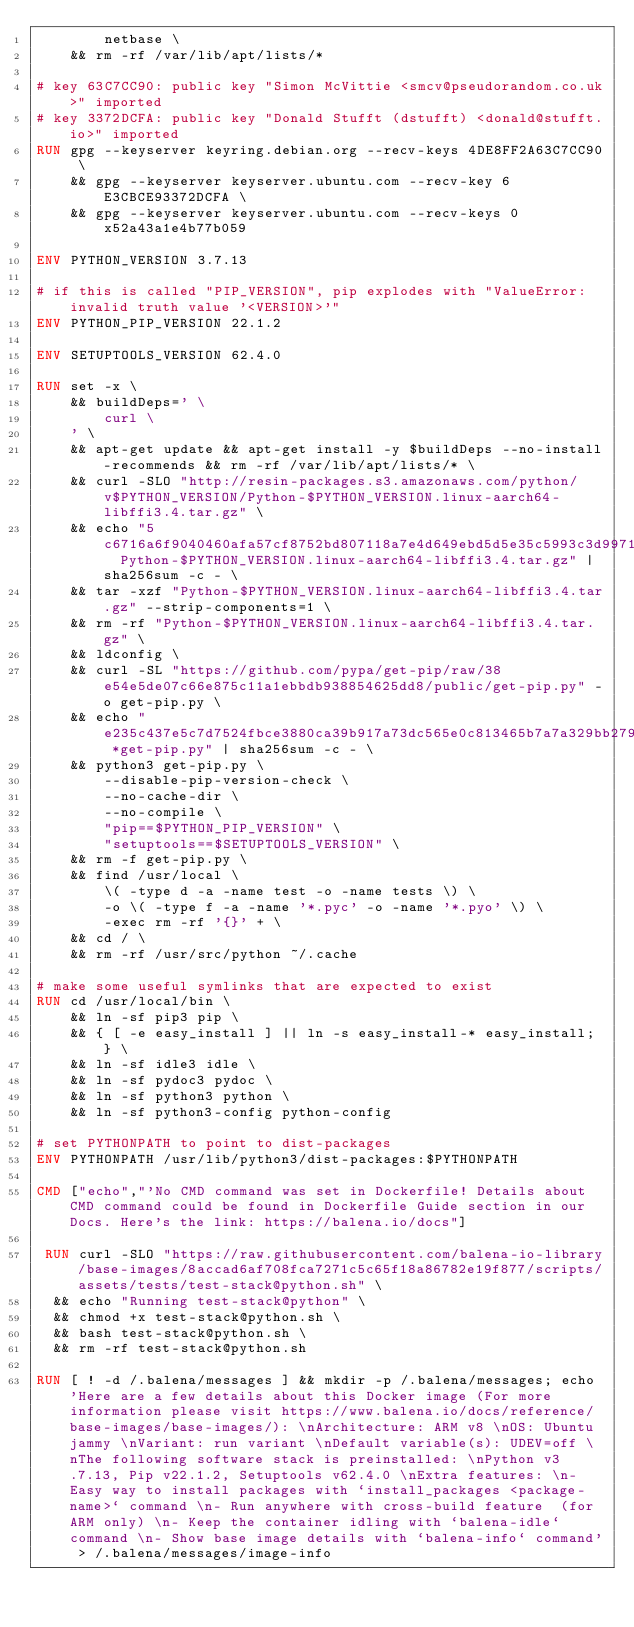Convert code to text. <code><loc_0><loc_0><loc_500><loc_500><_Dockerfile_>		netbase \
	&& rm -rf /var/lib/apt/lists/*

# key 63C7CC90: public key "Simon McVittie <smcv@pseudorandom.co.uk>" imported
# key 3372DCFA: public key "Donald Stufft (dstufft) <donald@stufft.io>" imported
RUN gpg --keyserver keyring.debian.org --recv-keys 4DE8FF2A63C7CC90 \
	&& gpg --keyserver keyserver.ubuntu.com --recv-key 6E3CBCE93372DCFA \
	&& gpg --keyserver keyserver.ubuntu.com --recv-keys 0x52a43a1e4b77b059

ENV PYTHON_VERSION 3.7.13

# if this is called "PIP_VERSION", pip explodes with "ValueError: invalid truth value '<VERSION>'"
ENV PYTHON_PIP_VERSION 22.1.2

ENV SETUPTOOLS_VERSION 62.4.0

RUN set -x \
	&& buildDeps=' \
		curl \
	' \
	&& apt-get update && apt-get install -y $buildDeps --no-install-recommends && rm -rf /var/lib/apt/lists/* \
	&& curl -SLO "http://resin-packages.s3.amazonaws.com/python/v$PYTHON_VERSION/Python-$PYTHON_VERSION.linux-aarch64-libffi3.4.tar.gz" \
	&& echo "5c6716a6f9040460afa57cf8752bd807118a7e4d649ebd5d5e35c5993c3d9971  Python-$PYTHON_VERSION.linux-aarch64-libffi3.4.tar.gz" | sha256sum -c - \
	&& tar -xzf "Python-$PYTHON_VERSION.linux-aarch64-libffi3.4.tar.gz" --strip-components=1 \
	&& rm -rf "Python-$PYTHON_VERSION.linux-aarch64-libffi3.4.tar.gz" \
	&& ldconfig \
	&& curl -SL "https://github.com/pypa/get-pip/raw/38e54e5de07c66e875c11a1ebbdb938854625dd8/public/get-pip.py" -o get-pip.py \
    && echo "e235c437e5c7d7524fbce3880ca39b917a73dc565e0c813465b7a7a329bb279a *get-pip.py" | sha256sum -c - \
    && python3 get-pip.py \
        --disable-pip-version-check \
        --no-cache-dir \
        --no-compile \
        "pip==$PYTHON_PIP_VERSION" \
        "setuptools==$SETUPTOOLS_VERSION" \
	&& rm -f get-pip.py \
	&& find /usr/local \
		\( -type d -a -name test -o -name tests \) \
		-o \( -type f -a -name '*.pyc' -o -name '*.pyo' \) \
		-exec rm -rf '{}' + \
	&& cd / \
	&& rm -rf /usr/src/python ~/.cache

# make some useful symlinks that are expected to exist
RUN cd /usr/local/bin \
	&& ln -sf pip3 pip \
	&& { [ -e easy_install ] || ln -s easy_install-* easy_install; } \
	&& ln -sf idle3 idle \
	&& ln -sf pydoc3 pydoc \
	&& ln -sf python3 python \
	&& ln -sf python3-config python-config

# set PYTHONPATH to point to dist-packages
ENV PYTHONPATH /usr/lib/python3/dist-packages:$PYTHONPATH

CMD ["echo","'No CMD command was set in Dockerfile! Details about CMD command could be found in Dockerfile Guide section in our Docs. Here's the link: https://balena.io/docs"]

 RUN curl -SLO "https://raw.githubusercontent.com/balena-io-library/base-images/8accad6af708fca7271c5c65f18a86782e19f877/scripts/assets/tests/test-stack@python.sh" \
  && echo "Running test-stack@python" \
  && chmod +x test-stack@python.sh \
  && bash test-stack@python.sh \
  && rm -rf test-stack@python.sh 

RUN [ ! -d /.balena/messages ] && mkdir -p /.balena/messages; echo 'Here are a few details about this Docker image (For more information please visit https://www.balena.io/docs/reference/base-images/base-images/): \nArchitecture: ARM v8 \nOS: Ubuntu jammy \nVariant: run variant \nDefault variable(s): UDEV=off \nThe following software stack is preinstalled: \nPython v3.7.13, Pip v22.1.2, Setuptools v62.4.0 \nExtra features: \n- Easy way to install packages with `install_packages <package-name>` command \n- Run anywhere with cross-build feature  (for ARM only) \n- Keep the container idling with `balena-idle` command \n- Show base image details with `balena-info` command' > /.balena/messages/image-info</code> 